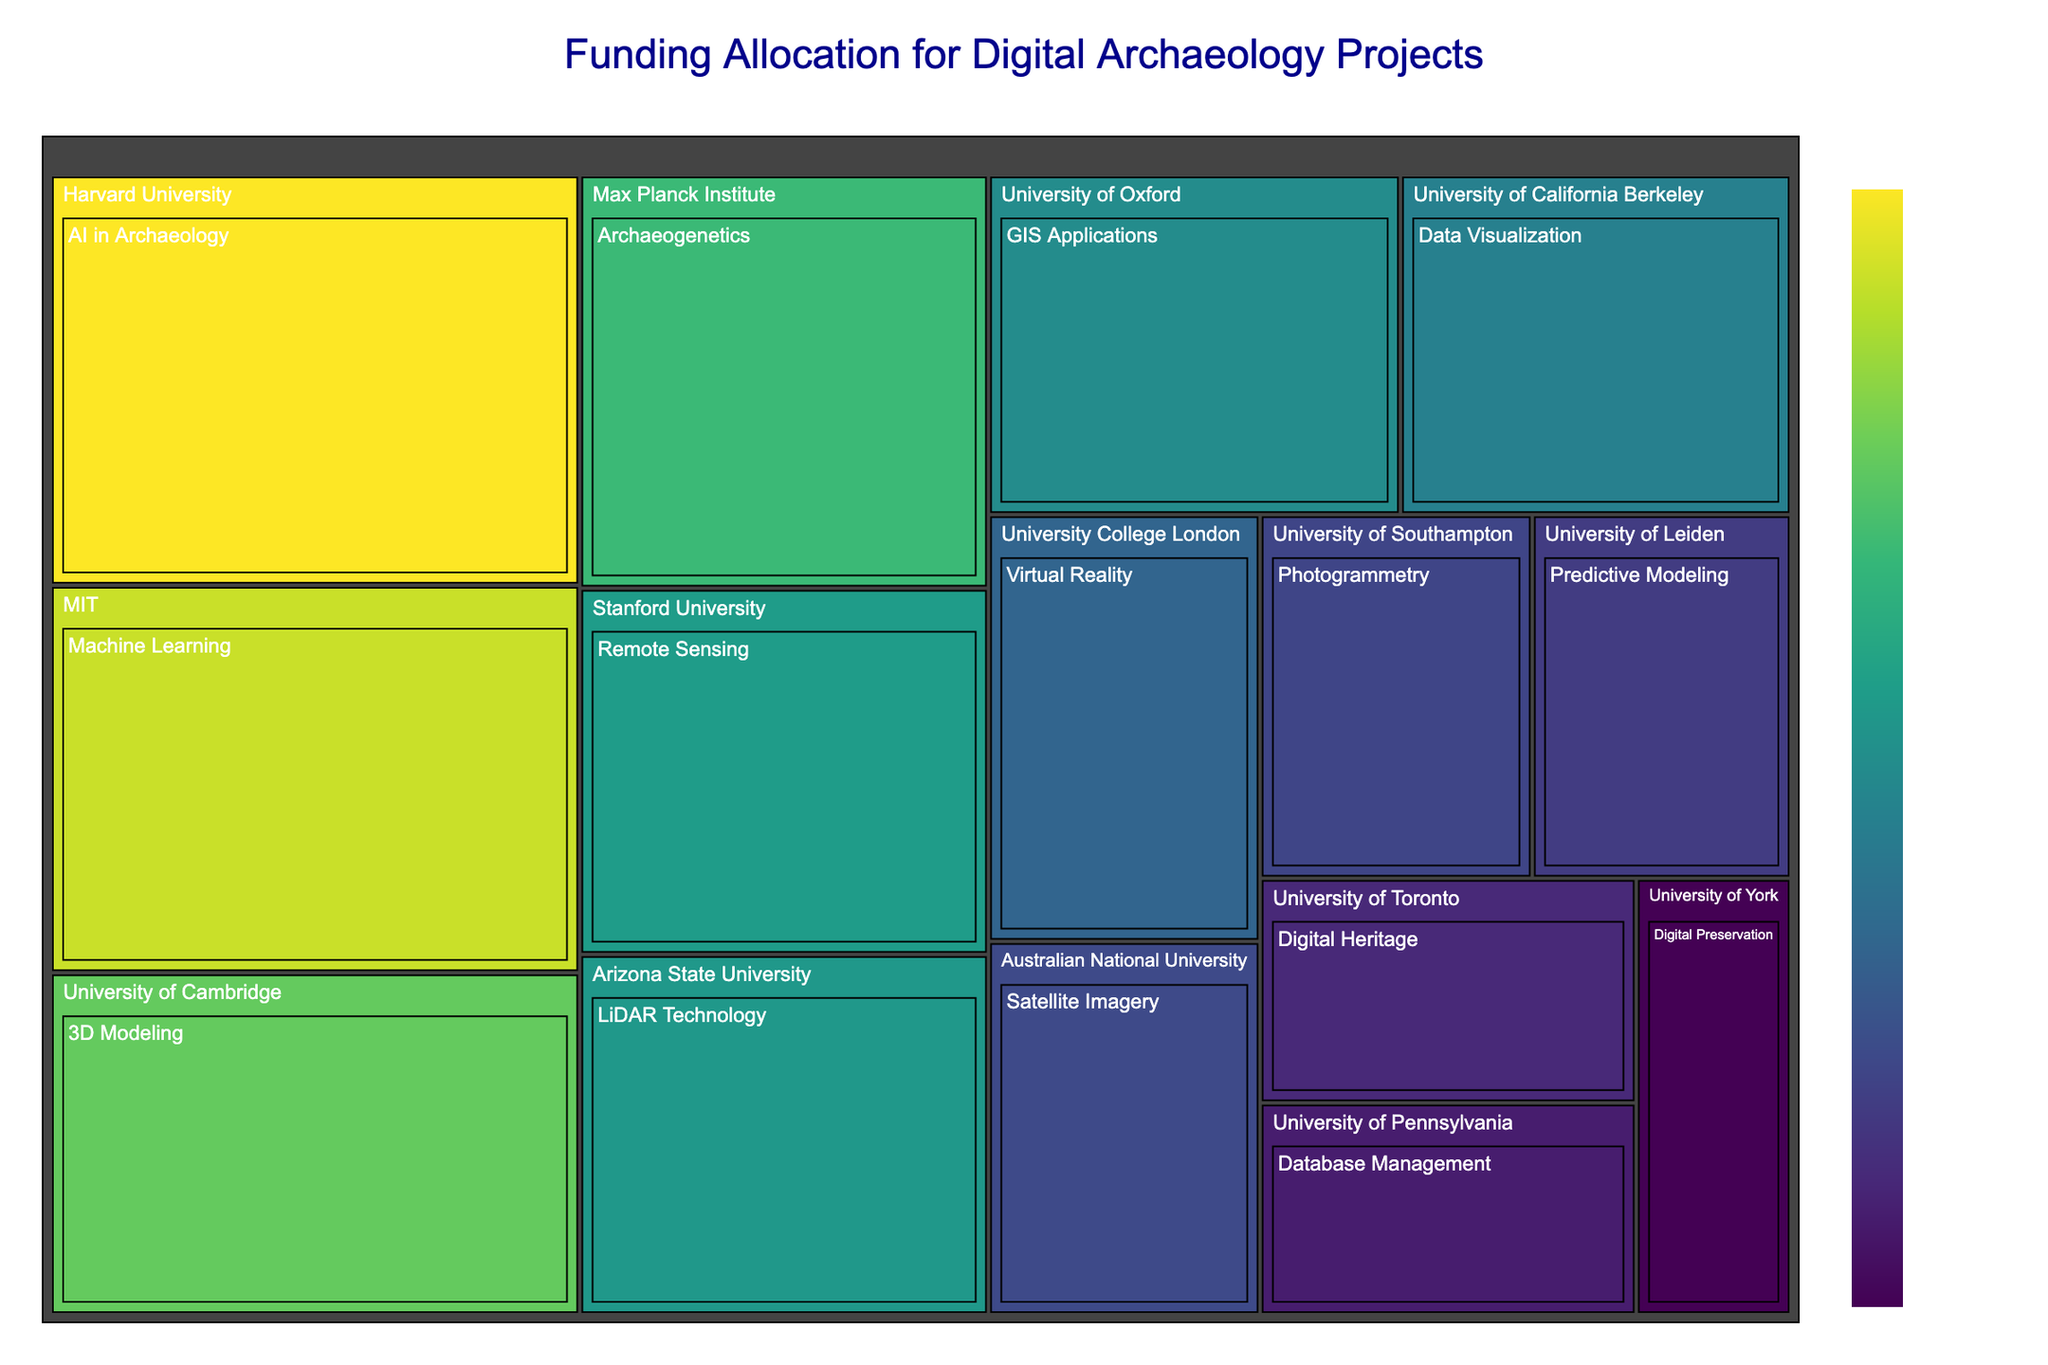What's the title of the treemap? The title is usually placed at the top of the treemap. It helps us understand the primary subject of the visualization.
Answer: Funding Allocation for Digital Archaeology Projects Which institution received the highest funding? The largest segment in the treemap generally represents the institution with the highest funding. By looking for the largest block, we can identify the institution.
Answer: Harvard University How much funding did Harvard University receive for AI in Archaeology? Locate the segment labeled "Harvard University" and read the corresponding funding amount for the "AI in Archaeology" research area.
Answer: $900,000 Which research area received the least funding? Look for the smallest segment on the treemap, which represents the area with the least funding.
Answer: Digital Preservation Compare the funding amounts for 3D Modeling at the University of Cambridge and Remote Sensing at Stanford University. Which one received more funding? Identify both segments on the treemap, then compare their funding amounts.
Answer: 3D Modeling at the University of Cambridge What is the total funding received by universities for Machine Learning and AI in Archaeology combined? Identify the segments for both "Machine Learning" (MIT) and "AI in Archaeology" (Harvard University). Sum their funding amounts: $850,000 (MIT) + $900,000 (Harvard University).
Answer: $1,750,000 Calculate the average funding amount across all institutions. Sum all the funding amounts in the treemap, then divide by the number of institutions (15). Total funding = $8,220,000, Number of institutions = 15, Average = $8,220,000 / 15.
Answer: $548,000 Which institution received more funding for Virtual Reality or Remote Sensing, and by how much? Identify the funding amounts for "Virtual Reality" (University College London) and "Remote Sensing" (Stanford University). Subtract the smaller amount from the larger one to find the difference.
Answer: Remote Sensing by $140,000 What percentage of the total funding did the University of York receive? Find the funding amount for the University of York ($280,000). Divide this by the total funding ($8,220,000) and multiply by 100 to get the percentage.
Answer: 3.41% Identify which research area is funded by the Max Planck Institute and the corresponding funding amount. Locate the segment labeled "Max Planck Institute" and note the corresponding research area and the funding amount.
Answer: Archaeogenetics, $700,000 